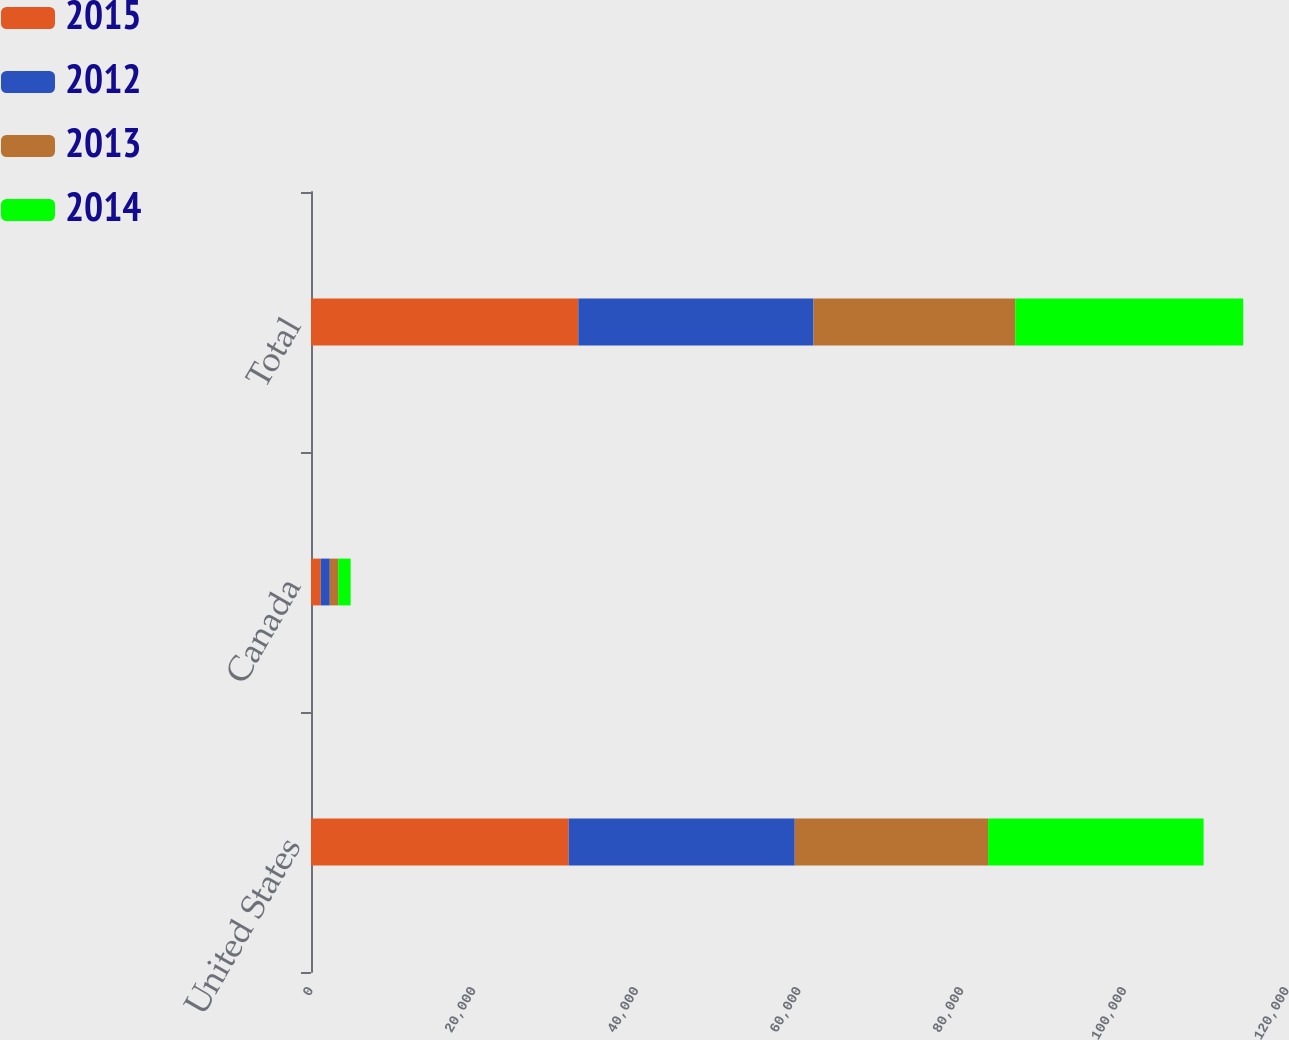Convert chart to OTSL. <chart><loc_0><loc_0><loc_500><loc_500><stacked_bar_chart><ecel><fcel>United States<fcel>Canada<fcel>Total<nl><fcel>2015<fcel>31677<fcel>1192<fcel>32869<nl><fcel>2012<fcel>27800<fcel>1118<fcel>28918<nl><fcel>2013<fcel>23770<fcel>1031<fcel>24801<nl><fcel>2014<fcel>26500<fcel>1533<fcel>28033<nl></chart> 